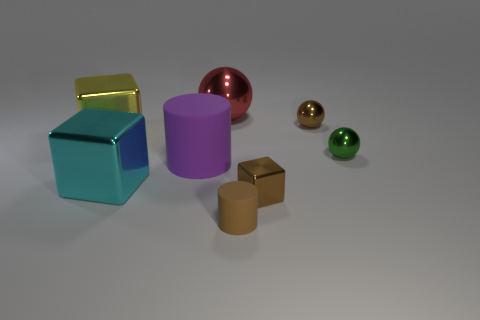Add 1 large brown matte cubes. How many objects exist? 9 Subtract all cubes. How many objects are left? 5 Add 7 tiny rubber objects. How many tiny rubber objects are left? 8 Add 7 small yellow rubber objects. How many small yellow rubber objects exist? 7 Subtract 0 yellow spheres. How many objects are left? 8 Subtract all big yellow metallic cylinders. Subtract all cyan things. How many objects are left? 7 